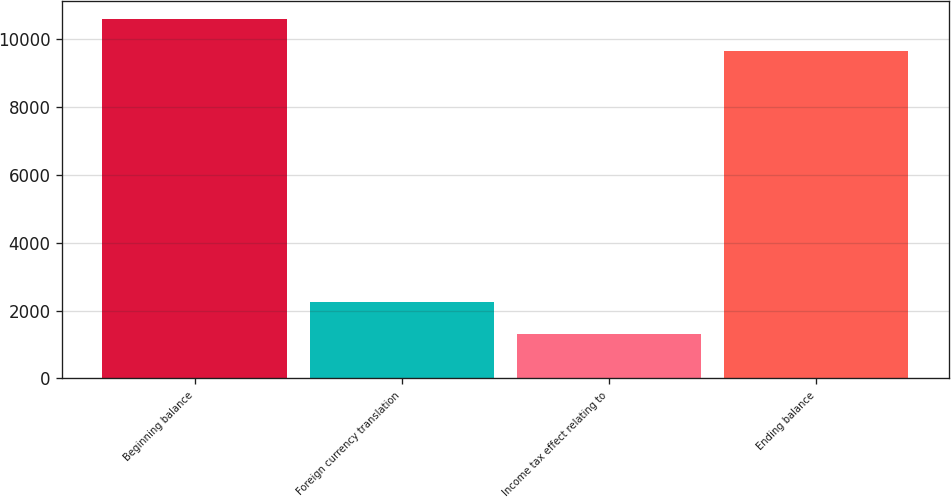<chart> <loc_0><loc_0><loc_500><loc_500><bar_chart><fcel>Beginning balance<fcel>Foreign currency translation<fcel>Income tax effect relating to<fcel>Ending balance<nl><fcel>10595.6<fcel>2240.6<fcel>1314<fcel>9669<nl></chart> 